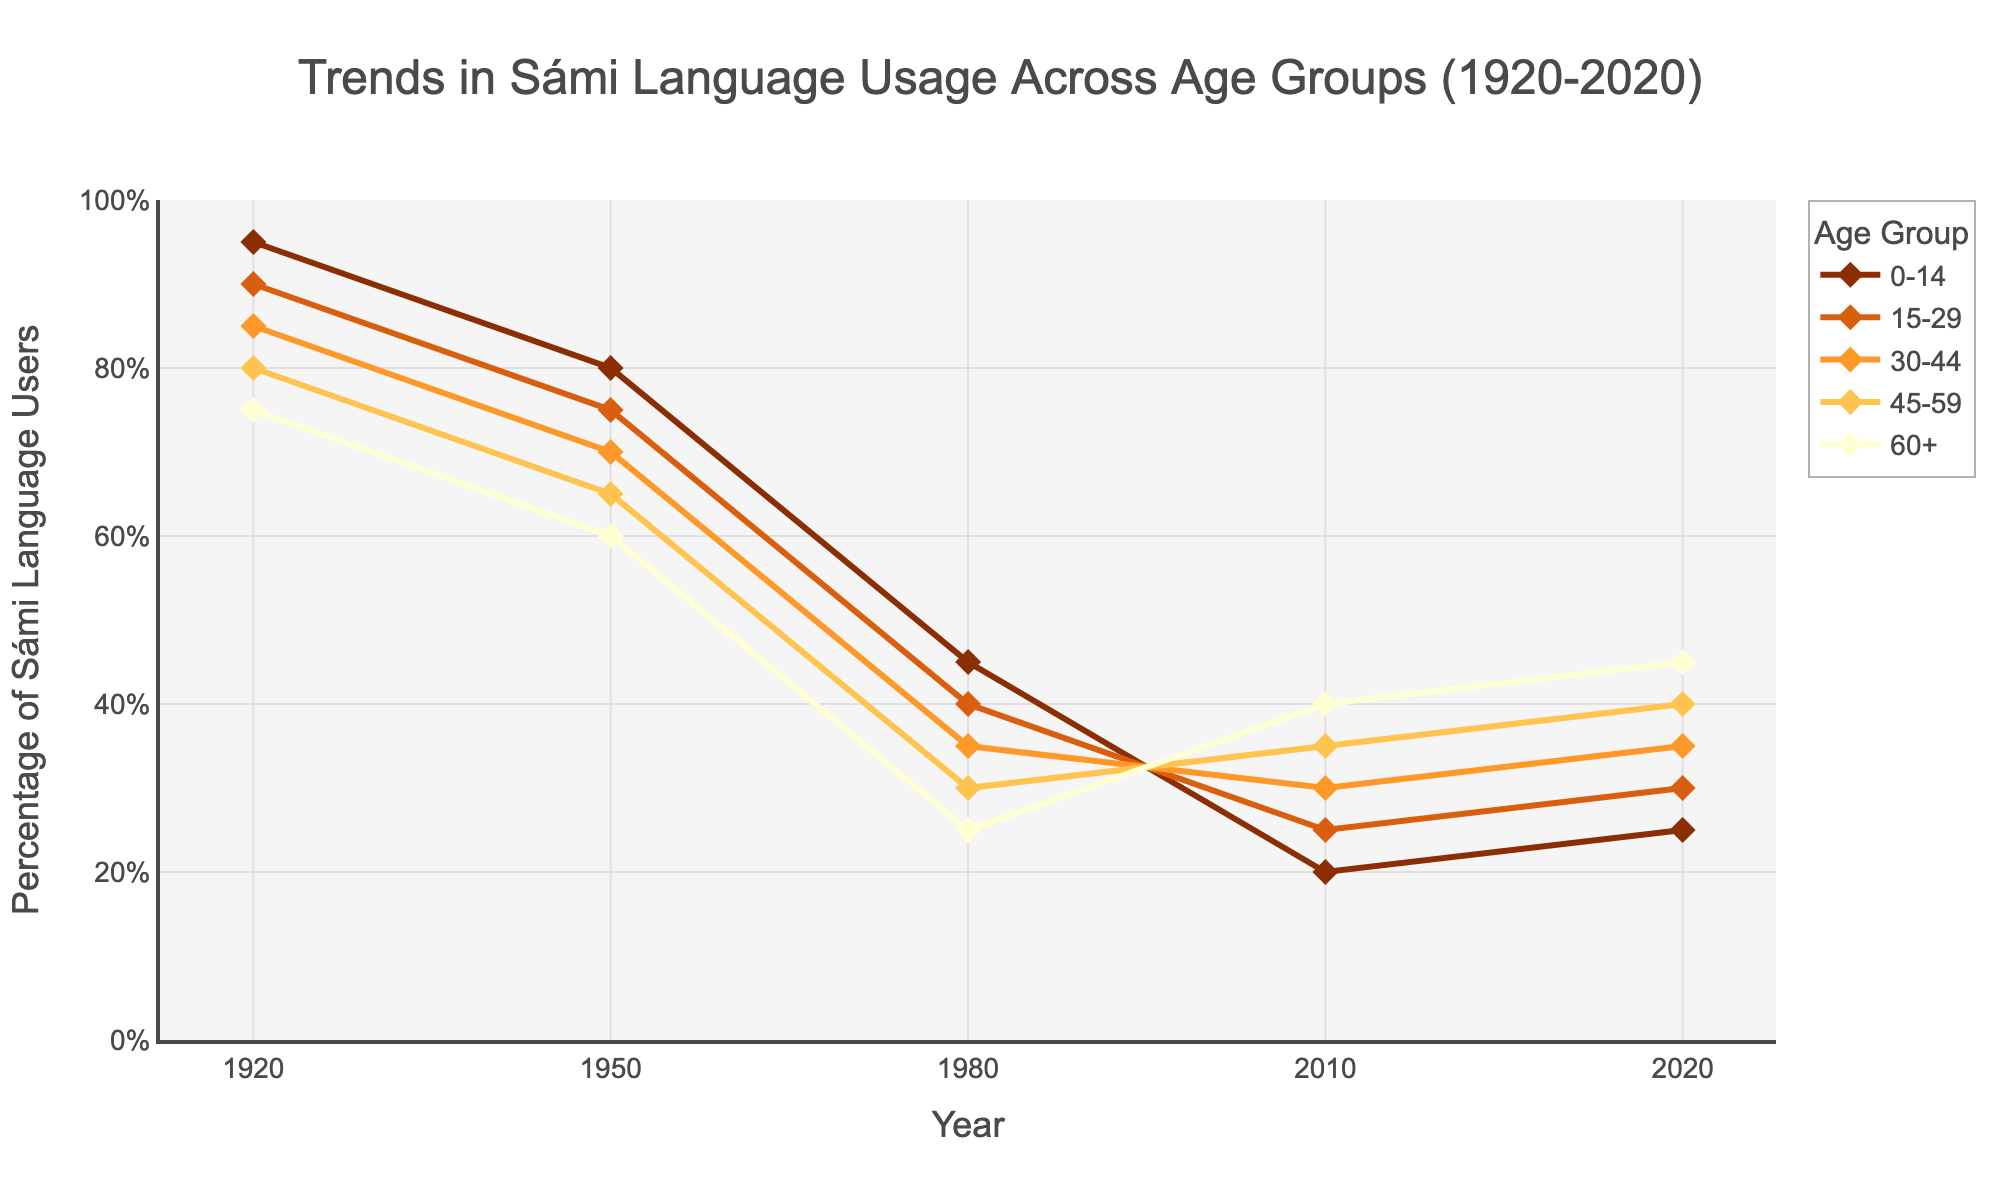What is the trend in Sámi language usage for the 0-14 age group from 1920 to 2020? The usage percentage for the 0-14 age group starts at 95% in 1920, gradually declines to 20% by 2010, and slightly increases to 25% by 2020.
Answer: Decline, then slight increase Which age group had the highest usage percentage in 2020? The 60+ age group had the highest usage percentage in 2020, with 45%.
Answer: 60+ How did the Sámi language usage among the 45-59 age group change between 1950 and 2020? In 1950, the usage was 65%. It decreased to 30% in 1980, then gradually increased to 40% by 2020.
Answer: Decreased, then increased In which year did the 30-44 age group have the same usage percentage as the 60+ age group? In 1980, both the 30-44 age group and the 60+ age group had a usage percentage of 25%.
Answer: 1980 What is the overall trend in Sámi language usage across all age groups over the past century? The trend shows a significant decline in usage from 1920 to 1980, followed by a slow but steady increase from 1980 to 2020.
Answer: Decline, then slight increase Compare the usage percentage of the 0-14 age group and the 15-29 age group in 2010. Which group had a higher percentage, and by how much? In 2010, the 0-14 age group had 20%, and the 15-29 age group had 25%. The 15-29 age group had a 5% higher usage.
Answer: 15-29 age group, by 5% What is the difference in usage percentage between the 30-44 age group in 1920 and 2020? In 1920, the usage was 85%, and in 2020, it was 35%. The difference is 85% - 35% = 50%.
Answer: 50% Which color represents the 15-29 age group in the figure? The color representing the 15-29 age group is orange.
Answer: Orange Between 1980 and 2020, which age group shows the most substantial increase in usage percentage? The 60+ age group shows the most substantial increase, from 25% to 45%, an increase of 20%.
Answer: 60+ What's the sum of the usage percentages of all age groups in 1950? The percentages for 1950 are 80, 75, 70, 65, and 60. Summing these up: 80 + 75 + 70 + 65 + 60 = 350.
Answer: 350 